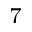<formula> <loc_0><loc_0><loc_500><loc_500>^ { 7 }</formula> 